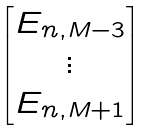<formula> <loc_0><loc_0><loc_500><loc_500>\begin{bmatrix} E _ { n , M - 3 } \\ \vdots \\ E _ { n , M + 1 } \end{bmatrix}</formula> 